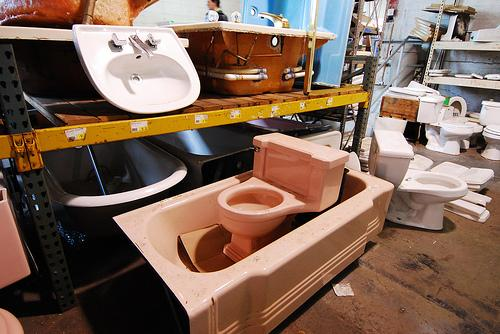Count the number of objects in the image related to the sink and describe their purpose. There are six objects related to the sink: the sink itself, a faucet, a left knob, and a right knob for controlling water flow, and two sink handles. What kind of sentiment does this image evoke? The image evokes a quirky and unusual sentiment due to the placement of the toilet inside the bathtub. In a few words, describe the overall scene in the image. The image shows a pink toilet inside a bathtub and a white sink on a shelf in a bathroom with a wooden floor. How many faucets are visible in the image, and what is their material? There is one faucet visible in the image, and it is made of metal. What is the primary color of the toilet in the bathtub? The primary color of the toilet in the bathtub is pink. Identify the color of the sink in the image. The sink is white in color. What type of material is the floor in the image made of? The floor in the image is made of wood. Briefly describe the positioning of the toilet in the image. The toilet is positioned inside a bathtub. Determine if there is any complex reasoning presented in the image, such as cause and effect or problem-solving. No complex reasoning is apparent in the image, as it merely presents a scenario of a toilet inside a bathtub and a sink on a shelf. 